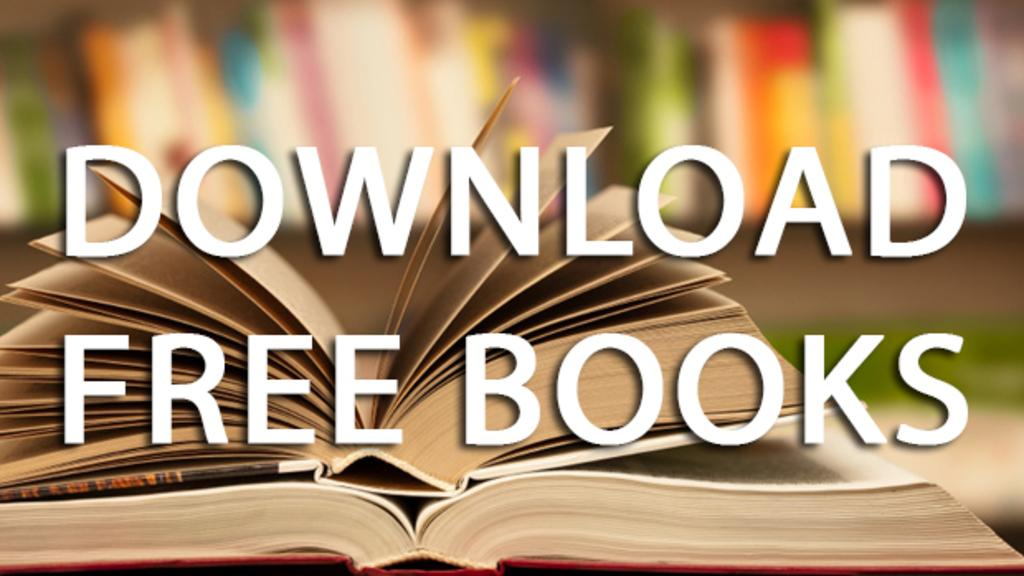Provide a one-sentence caption for the provided image. A sign tells us that we can download free books. 